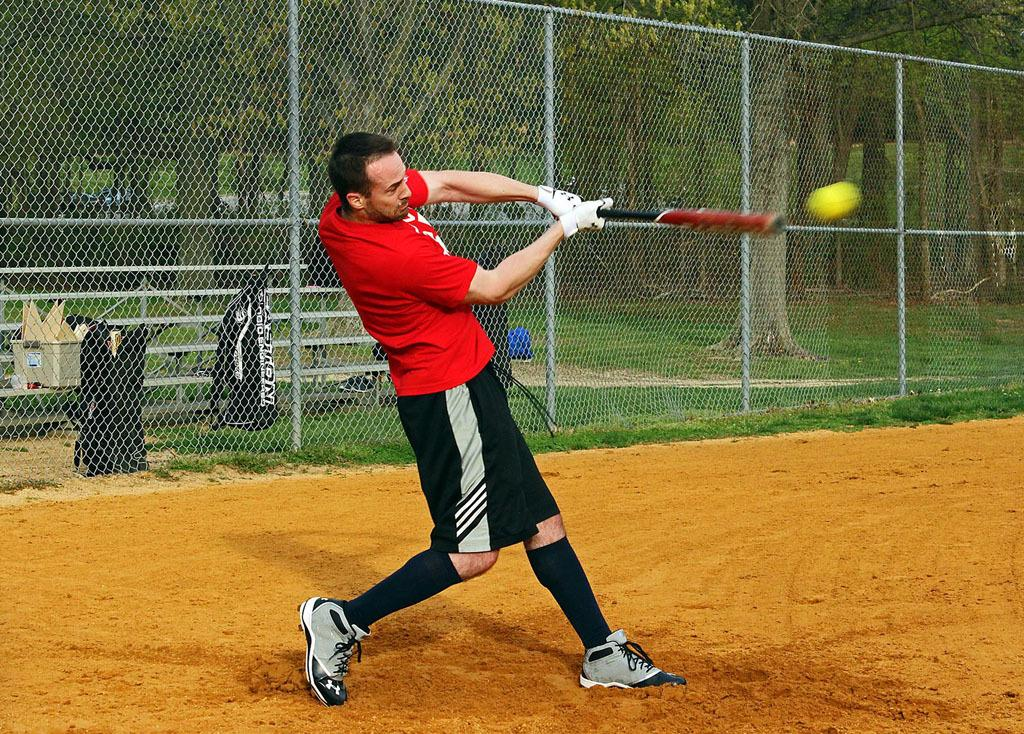What is the man in the image doing? The man is playing hockey in the image. Where is the hockey game taking place? The hockey game is taking place on a ground. What can be seen behind the man? There is a fence behind the man. What is located beyond the fence? There are garbage bags beyond the fence. What can be seen in the distance in the image? There are trees visible in the background. What type of weather can be seen in the image? The provided facts do not mention any details about the weather in the image. What is the man using to cut the cabbage in the image? There is no cabbage or cutting tool present in the image; the man is playing hockey. 